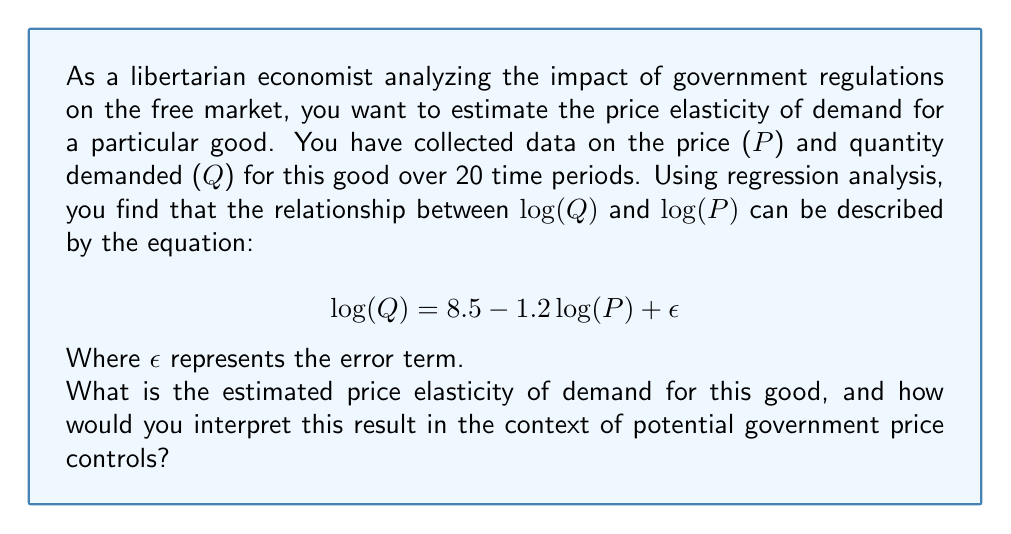Show me your answer to this math problem. To solve this problem, we need to understand the following concepts:

1. Price elasticity of demand measures the responsiveness of quantity demanded to changes in price.

2. In a log-log regression model, the coefficient of log(P) directly represents the price elasticity of demand.

3. The equation given is in the form of a log-log model:

   $$\log(Q) = \beta_0 + \beta_1\log(P) + \epsilon$$

   Where $\beta_0$ is the intercept and $\beta_1$ is the coefficient of log(P).

4. In this case, $\beta_0 = 8.5$ and $\beta_1 = -1.2$.

5. The price elasticity of demand is the absolute value of $\beta_1$.

Therefore, the estimated price elasticity of demand is |-1.2| = 1.2.

Interpretation:
- The price elasticity of demand is 1.2, which means the demand is elastic.
- For every 1% increase in price, the quantity demanded decreases by approximately 1.2%.
- Conversely, for every 1% decrease in price, the quantity demanded increases by approximately 1.2%.

In the context of potential government price controls:
- This elastic demand suggests that consumers are relatively sensitive to price changes.
- If the government were to impose price controls (e.g., a price ceiling), it could lead to significant changes in the quantity demanded.
- From a libertarian perspective, this elasticity indicates that the market is responsive to price signals, and government intervention might disrupt this natural market mechanism, potentially leading to inefficiencies or shortages.
Answer: The estimated price elasticity of demand is 1.2, indicating elastic demand. This suggests that consumers are sensitive to price changes, with a 1% increase in price leading to a 1.2% decrease in quantity demanded, and vice versa. From a libertarian economic perspective, this elasticity demonstrates the market's responsiveness to price signals, highlighting the potential negative consequences of government price controls on market efficiency. 